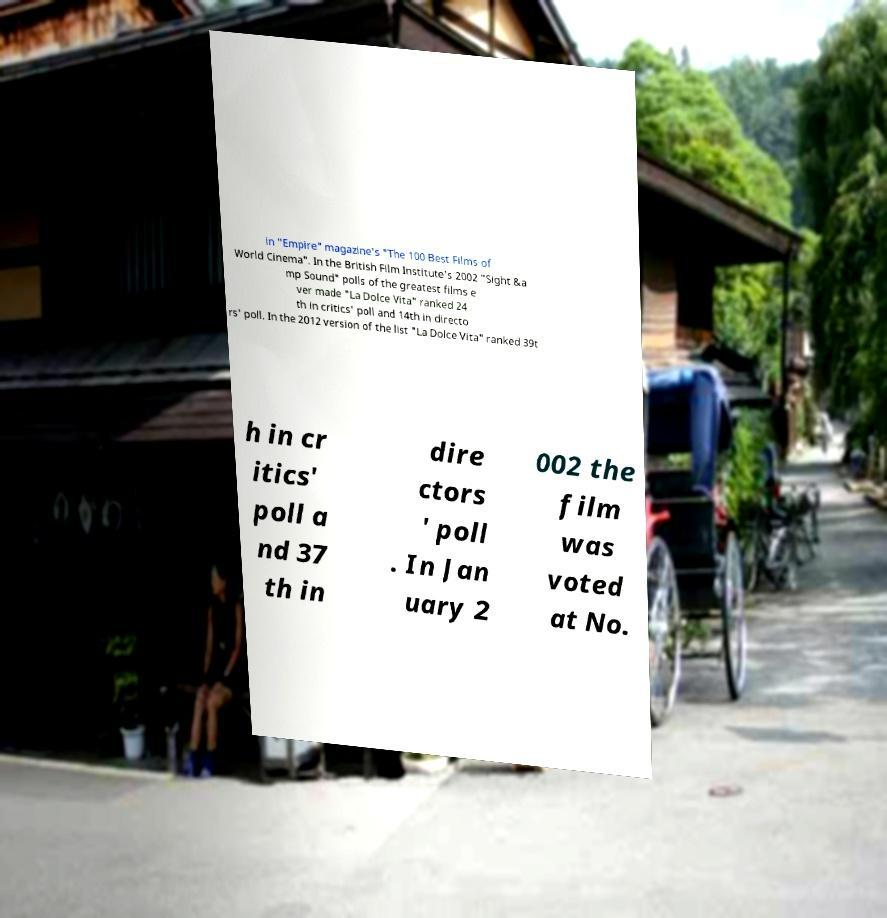Could you assist in decoding the text presented in this image and type it out clearly? in "Empire" magazine's "The 100 Best Films of World Cinema". In the British Film Institute's 2002 "Sight &a mp Sound" polls of the greatest films e ver made "La Dolce Vita" ranked 24 th in critics' poll and 14th in directo rs' poll. In the 2012 version of the list "La Dolce Vita" ranked 39t h in cr itics' poll a nd 37 th in dire ctors ' poll . In Jan uary 2 002 the film was voted at No. 